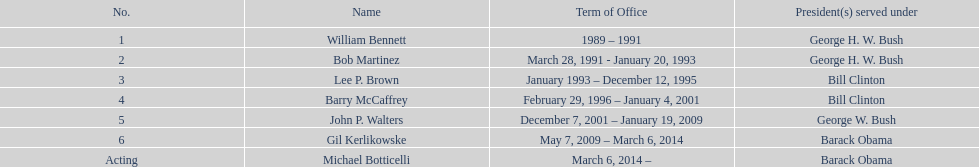Who serves inder barack obama? Gil Kerlikowske. Could you parse the entire table? {'header': ['No.', 'Name', 'Term of Office', 'President(s) served under'], 'rows': [['1', 'William Bennett', '1989 – 1991', 'George H. W. Bush'], ['2', 'Bob Martinez', 'March 28, 1991 - January 20, 1993', 'George H. W. Bush'], ['3', 'Lee P. Brown', 'January 1993 – December 12, 1995', 'Bill Clinton'], ['4', 'Barry McCaffrey', 'February 29, 1996 – January 4, 2001', 'Bill Clinton'], ['5', 'John P. Walters', 'December 7, 2001 – January 19, 2009', 'George W. Bush'], ['6', 'Gil Kerlikowske', 'May 7, 2009 – March 6, 2014', 'Barack Obama'], ['Acting', 'Michael Botticelli', 'March 6, 2014 –', 'Barack Obama']]} 